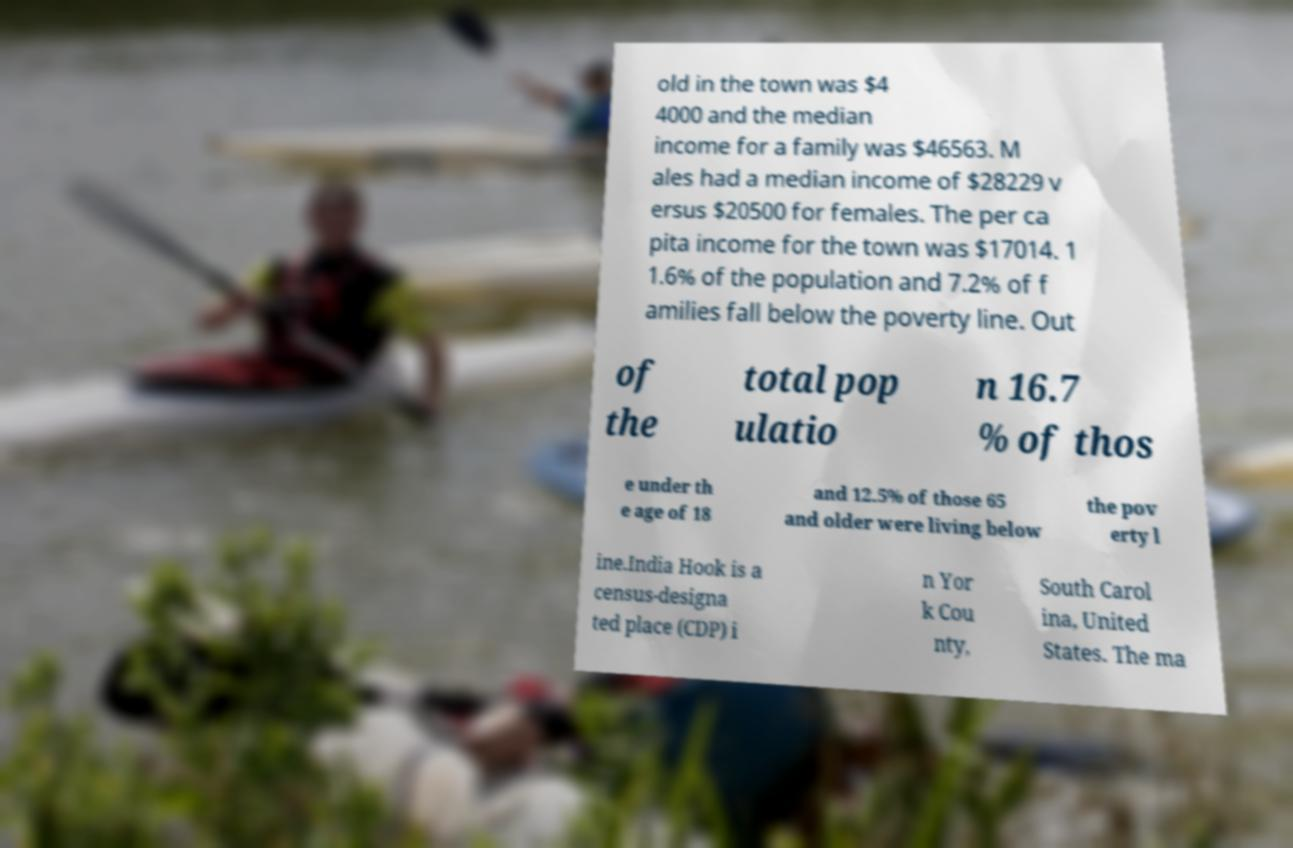What messages or text are displayed in this image? I need them in a readable, typed format. old in the town was $4 4000 and the median income for a family was $46563. M ales had a median income of $28229 v ersus $20500 for females. The per ca pita income for the town was $17014. 1 1.6% of the population and 7.2% of f amilies fall below the poverty line. Out of the total pop ulatio n 16.7 % of thos e under th e age of 18 and 12.5% of those 65 and older were living below the pov erty l ine.India Hook is a census-designa ted place (CDP) i n Yor k Cou nty, South Carol ina, United States. The ma 